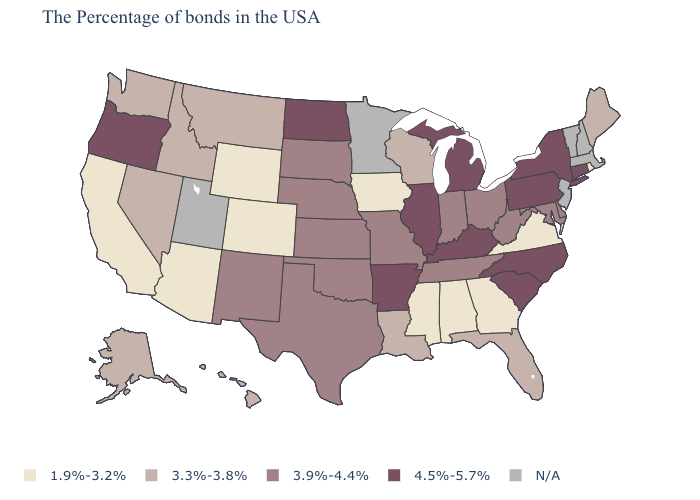Does the first symbol in the legend represent the smallest category?
Keep it brief. Yes. Does Nebraska have the lowest value in the MidWest?
Give a very brief answer. No. How many symbols are there in the legend?
Concise answer only. 5. Name the states that have a value in the range 1.9%-3.2%?
Concise answer only. Rhode Island, Virginia, Georgia, Alabama, Mississippi, Iowa, Wyoming, Colorado, Arizona, California. Does Oregon have the highest value in the West?
Write a very short answer. Yes. Name the states that have a value in the range 3.9%-4.4%?
Answer briefly. Delaware, Maryland, West Virginia, Ohio, Indiana, Tennessee, Missouri, Kansas, Nebraska, Oklahoma, Texas, South Dakota, New Mexico. Among the states that border Iowa , does Wisconsin have the lowest value?
Give a very brief answer. Yes. Among the states that border Washington , does Idaho have the highest value?
Short answer required. No. What is the value of Michigan?
Quick response, please. 4.5%-5.7%. What is the value of Oklahoma?
Short answer required. 3.9%-4.4%. Does Florida have the highest value in the South?
Quick response, please. No. What is the value of Florida?
Short answer required. 3.3%-3.8%. Name the states that have a value in the range 1.9%-3.2%?
Concise answer only. Rhode Island, Virginia, Georgia, Alabama, Mississippi, Iowa, Wyoming, Colorado, Arizona, California. Among the states that border Missouri , which have the lowest value?
Quick response, please. Iowa. Does Oregon have the highest value in the West?
Quick response, please. Yes. 